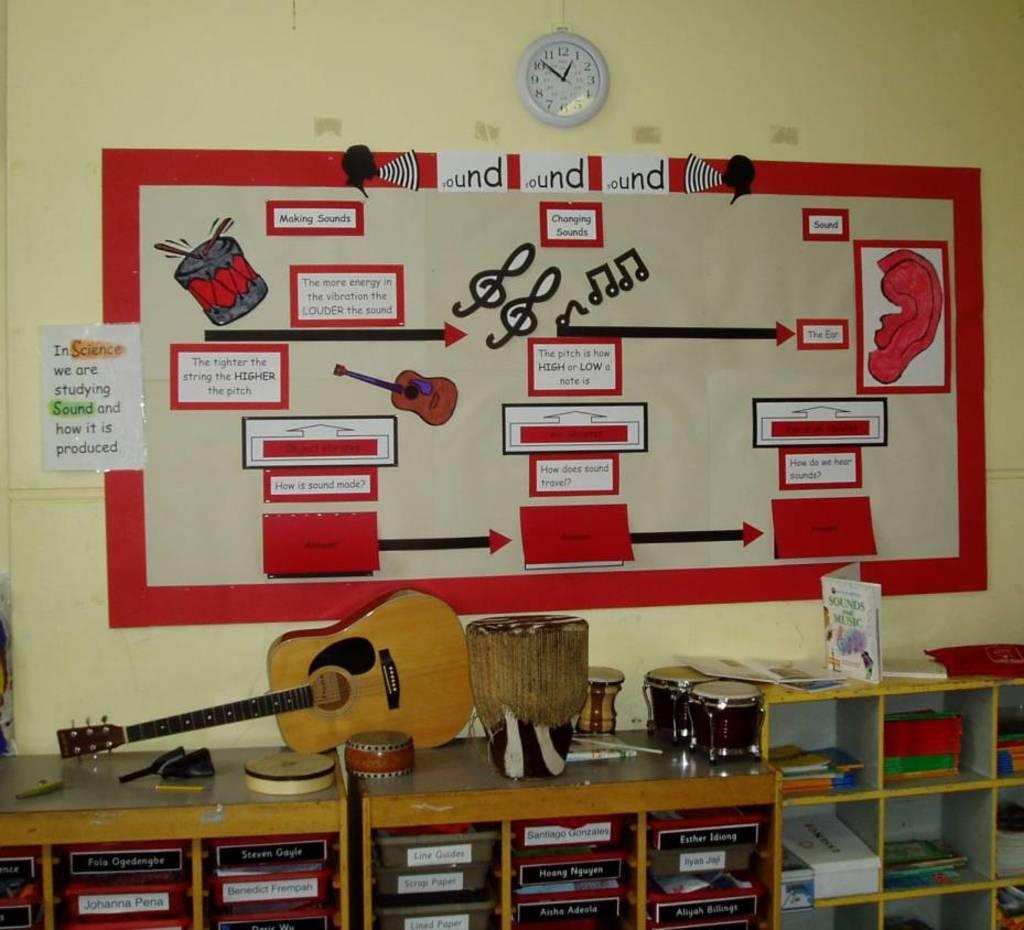In one or two sentences, can you explain what this image depicts? In this image there are desks towards the bottom of the image, there are objects on the desks, there are papers, there is text on the paper, there is a chart, there is a board, there is a wall clock, at the background of the image there is a wall. 